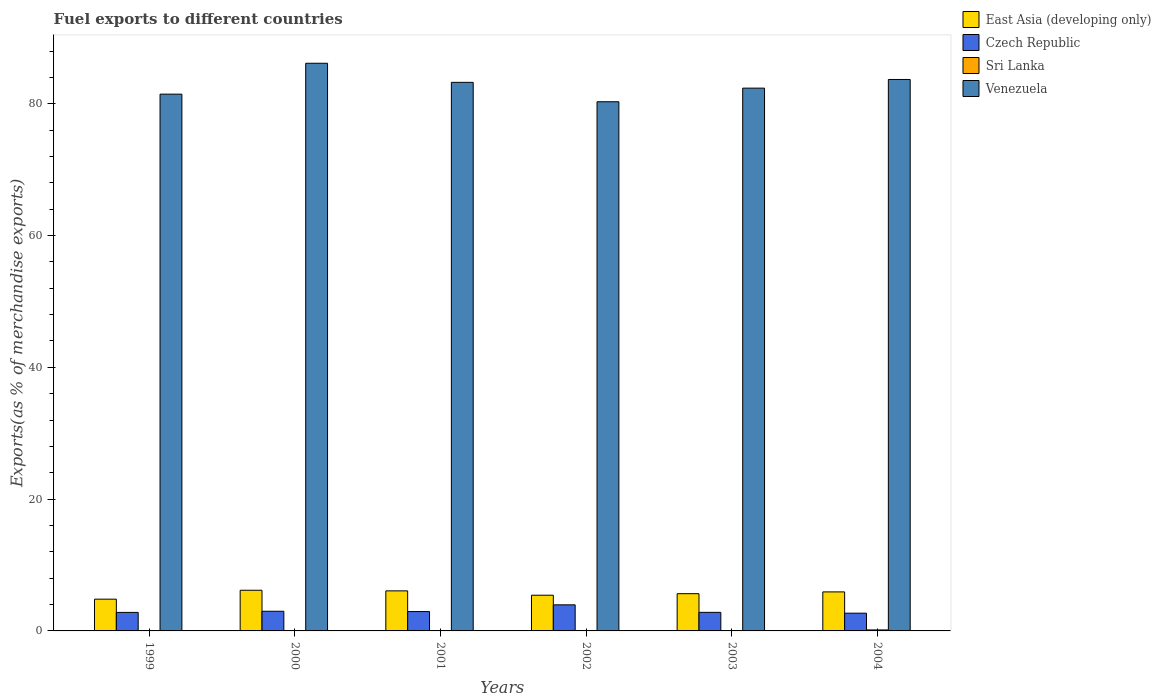How many bars are there on the 6th tick from the left?
Your response must be concise. 4. How many bars are there on the 2nd tick from the right?
Your answer should be very brief. 4. In how many cases, is the number of bars for a given year not equal to the number of legend labels?
Your answer should be compact. 0. What is the percentage of exports to different countries in Venezuela in 2002?
Offer a terse response. 80.3. Across all years, what is the maximum percentage of exports to different countries in Sri Lanka?
Your answer should be compact. 0.15. Across all years, what is the minimum percentage of exports to different countries in East Asia (developing only)?
Make the answer very short. 4.82. What is the total percentage of exports to different countries in Sri Lanka in the graph?
Offer a terse response. 0.24. What is the difference between the percentage of exports to different countries in Czech Republic in 2000 and that in 2001?
Your response must be concise. 0.04. What is the difference between the percentage of exports to different countries in Sri Lanka in 2000 and the percentage of exports to different countries in East Asia (developing only) in 1999?
Make the answer very short. -4.81. What is the average percentage of exports to different countries in East Asia (developing only) per year?
Ensure brevity in your answer.  5.68. In the year 2003, what is the difference between the percentage of exports to different countries in Sri Lanka and percentage of exports to different countries in Venezuela?
Your answer should be very brief. -82.35. In how many years, is the percentage of exports to different countries in East Asia (developing only) greater than 72 %?
Give a very brief answer. 0. What is the ratio of the percentage of exports to different countries in East Asia (developing only) in 2002 to that in 2003?
Offer a terse response. 0.96. Is the percentage of exports to different countries in Venezuela in 2000 less than that in 2001?
Provide a succinct answer. No. What is the difference between the highest and the second highest percentage of exports to different countries in Venezuela?
Your answer should be compact. 2.46. What is the difference between the highest and the lowest percentage of exports to different countries in Czech Republic?
Offer a very short reply. 1.27. Is the sum of the percentage of exports to different countries in East Asia (developing only) in 2001 and 2003 greater than the maximum percentage of exports to different countries in Sri Lanka across all years?
Your answer should be compact. Yes. Is it the case that in every year, the sum of the percentage of exports to different countries in East Asia (developing only) and percentage of exports to different countries in Venezuela is greater than the sum of percentage of exports to different countries in Sri Lanka and percentage of exports to different countries in Czech Republic?
Offer a very short reply. No. What does the 1st bar from the left in 2001 represents?
Ensure brevity in your answer.  East Asia (developing only). What does the 1st bar from the right in 2002 represents?
Ensure brevity in your answer.  Venezuela. Are all the bars in the graph horizontal?
Provide a succinct answer. No. Are the values on the major ticks of Y-axis written in scientific E-notation?
Your answer should be very brief. No. Does the graph contain any zero values?
Give a very brief answer. No. How many legend labels are there?
Give a very brief answer. 4. What is the title of the graph?
Make the answer very short. Fuel exports to different countries. What is the label or title of the X-axis?
Offer a very short reply. Years. What is the label or title of the Y-axis?
Make the answer very short. Exports(as % of merchandise exports). What is the Exports(as % of merchandise exports) in East Asia (developing only) in 1999?
Provide a short and direct response. 4.82. What is the Exports(as % of merchandise exports) of Czech Republic in 1999?
Offer a very short reply. 2.81. What is the Exports(as % of merchandise exports) of Sri Lanka in 1999?
Ensure brevity in your answer.  0.04. What is the Exports(as % of merchandise exports) of Venezuela in 1999?
Your response must be concise. 81.45. What is the Exports(as % of merchandise exports) in East Asia (developing only) in 2000?
Make the answer very short. 6.17. What is the Exports(as % of merchandise exports) of Czech Republic in 2000?
Keep it short and to the point. 2.98. What is the Exports(as % of merchandise exports) of Sri Lanka in 2000?
Your response must be concise. 0.01. What is the Exports(as % of merchandise exports) of Venezuela in 2000?
Keep it short and to the point. 86.14. What is the Exports(as % of merchandise exports) of East Asia (developing only) in 2001?
Provide a short and direct response. 6.08. What is the Exports(as % of merchandise exports) in Czech Republic in 2001?
Your answer should be compact. 2.94. What is the Exports(as % of merchandise exports) in Sri Lanka in 2001?
Ensure brevity in your answer.  0.01. What is the Exports(as % of merchandise exports) of Venezuela in 2001?
Ensure brevity in your answer.  83.24. What is the Exports(as % of merchandise exports) of East Asia (developing only) in 2002?
Offer a terse response. 5.42. What is the Exports(as % of merchandise exports) in Czech Republic in 2002?
Your answer should be compact. 3.96. What is the Exports(as % of merchandise exports) of Sri Lanka in 2002?
Give a very brief answer. 0.01. What is the Exports(as % of merchandise exports) in Venezuela in 2002?
Your response must be concise. 80.3. What is the Exports(as % of merchandise exports) of East Asia (developing only) in 2003?
Keep it short and to the point. 5.65. What is the Exports(as % of merchandise exports) of Czech Republic in 2003?
Offer a terse response. 2.82. What is the Exports(as % of merchandise exports) in Sri Lanka in 2003?
Offer a terse response. 0.02. What is the Exports(as % of merchandise exports) in Venezuela in 2003?
Offer a terse response. 82.37. What is the Exports(as % of merchandise exports) in East Asia (developing only) in 2004?
Your answer should be very brief. 5.92. What is the Exports(as % of merchandise exports) in Czech Republic in 2004?
Provide a short and direct response. 2.69. What is the Exports(as % of merchandise exports) in Sri Lanka in 2004?
Provide a short and direct response. 0.15. What is the Exports(as % of merchandise exports) in Venezuela in 2004?
Provide a succinct answer. 83.68. Across all years, what is the maximum Exports(as % of merchandise exports) of East Asia (developing only)?
Give a very brief answer. 6.17. Across all years, what is the maximum Exports(as % of merchandise exports) of Czech Republic?
Offer a terse response. 3.96. Across all years, what is the maximum Exports(as % of merchandise exports) in Sri Lanka?
Offer a very short reply. 0.15. Across all years, what is the maximum Exports(as % of merchandise exports) of Venezuela?
Offer a terse response. 86.14. Across all years, what is the minimum Exports(as % of merchandise exports) in East Asia (developing only)?
Your response must be concise. 4.82. Across all years, what is the minimum Exports(as % of merchandise exports) of Czech Republic?
Offer a terse response. 2.69. Across all years, what is the minimum Exports(as % of merchandise exports) of Sri Lanka?
Offer a very short reply. 0.01. Across all years, what is the minimum Exports(as % of merchandise exports) of Venezuela?
Offer a very short reply. 80.3. What is the total Exports(as % of merchandise exports) in East Asia (developing only) in the graph?
Make the answer very short. 34.06. What is the total Exports(as % of merchandise exports) in Czech Republic in the graph?
Give a very brief answer. 18.2. What is the total Exports(as % of merchandise exports) in Sri Lanka in the graph?
Your response must be concise. 0.24. What is the total Exports(as % of merchandise exports) in Venezuela in the graph?
Your response must be concise. 497.18. What is the difference between the Exports(as % of merchandise exports) in East Asia (developing only) in 1999 and that in 2000?
Your response must be concise. -1.35. What is the difference between the Exports(as % of merchandise exports) of Czech Republic in 1999 and that in 2000?
Ensure brevity in your answer.  -0.17. What is the difference between the Exports(as % of merchandise exports) of Sri Lanka in 1999 and that in 2000?
Make the answer very short. 0.03. What is the difference between the Exports(as % of merchandise exports) of Venezuela in 1999 and that in 2000?
Provide a succinct answer. -4.69. What is the difference between the Exports(as % of merchandise exports) of East Asia (developing only) in 1999 and that in 2001?
Your answer should be very brief. -1.26. What is the difference between the Exports(as % of merchandise exports) in Czech Republic in 1999 and that in 2001?
Offer a very short reply. -0.13. What is the difference between the Exports(as % of merchandise exports) in Sri Lanka in 1999 and that in 2001?
Give a very brief answer. 0.03. What is the difference between the Exports(as % of merchandise exports) of Venezuela in 1999 and that in 2001?
Keep it short and to the point. -1.79. What is the difference between the Exports(as % of merchandise exports) in East Asia (developing only) in 1999 and that in 2002?
Make the answer very short. -0.6. What is the difference between the Exports(as % of merchandise exports) in Czech Republic in 1999 and that in 2002?
Ensure brevity in your answer.  -1.15. What is the difference between the Exports(as % of merchandise exports) of Sri Lanka in 1999 and that in 2002?
Keep it short and to the point. 0.03. What is the difference between the Exports(as % of merchandise exports) in Venezuela in 1999 and that in 2002?
Your answer should be compact. 1.15. What is the difference between the Exports(as % of merchandise exports) in East Asia (developing only) in 1999 and that in 2003?
Give a very brief answer. -0.83. What is the difference between the Exports(as % of merchandise exports) of Czech Republic in 1999 and that in 2003?
Your answer should be very brief. -0.01. What is the difference between the Exports(as % of merchandise exports) of Sri Lanka in 1999 and that in 2003?
Ensure brevity in your answer.  0.02. What is the difference between the Exports(as % of merchandise exports) of Venezuela in 1999 and that in 2003?
Provide a short and direct response. -0.91. What is the difference between the Exports(as % of merchandise exports) in East Asia (developing only) in 1999 and that in 2004?
Your answer should be very brief. -1.1. What is the difference between the Exports(as % of merchandise exports) of Czech Republic in 1999 and that in 2004?
Keep it short and to the point. 0.12. What is the difference between the Exports(as % of merchandise exports) of Sri Lanka in 1999 and that in 2004?
Your response must be concise. -0.11. What is the difference between the Exports(as % of merchandise exports) of Venezuela in 1999 and that in 2004?
Provide a succinct answer. -2.23. What is the difference between the Exports(as % of merchandise exports) of East Asia (developing only) in 2000 and that in 2001?
Ensure brevity in your answer.  0.09. What is the difference between the Exports(as % of merchandise exports) in Czech Republic in 2000 and that in 2001?
Your answer should be very brief. 0.04. What is the difference between the Exports(as % of merchandise exports) in Sri Lanka in 2000 and that in 2001?
Provide a short and direct response. -0.01. What is the difference between the Exports(as % of merchandise exports) in Venezuela in 2000 and that in 2001?
Your answer should be compact. 2.9. What is the difference between the Exports(as % of merchandise exports) of East Asia (developing only) in 2000 and that in 2002?
Give a very brief answer. 0.75. What is the difference between the Exports(as % of merchandise exports) of Czech Republic in 2000 and that in 2002?
Your response must be concise. -0.97. What is the difference between the Exports(as % of merchandise exports) of Sri Lanka in 2000 and that in 2002?
Keep it short and to the point. -0. What is the difference between the Exports(as % of merchandise exports) in Venezuela in 2000 and that in 2002?
Make the answer very short. 5.84. What is the difference between the Exports(as % of merchandise exports) of East Asia (developing only) in 2000 and that in 2003?
Make the answer very short. 0.52. What is the difference between the Exports(as % of merchandise exports) of Czech Republic in 2000 and that in 2003?
Make the answer very short. 0.17. What is the difference between the Exports(as % of merchandise exports) in Sri Lanka in 2000 and that in 2003?
Make the answer very short. -0.01. What is the difference between the Exports(as % of merchandise exports) in Venezuela in 2000 and that in 2003?
Provide a succinct answer. 3.77. What is the difference between the Exports(as % of merchandise exports) in East Asia (developing only) in 2000 and that in 2004?
Your answer should be very brief. 0.25. What is the difference between the Exports(as % of merchandise exports) in Czech Republic in 2000 and that in 2004?
Provide a succinct answer. 0.29. What is the difference between the Exports(as % of merchandise exports) in Sri Lanka in 2000 and that in 2004?
Offer a very short reply. -0.14. What is the difference between the Exports(as % of merchandise exports) of Venezuela in 2000 and that in 2004?
Make the answer very short. 2.46. What is the difference between the Exports(as % of merchandise exports) in East Asia (developing only) in 2001 and that in 2002?
Offer a terse response. 0.66. What is the difference between the Exports(as % of merchandise exports) in Czech Republic in 2001 and that in 2002?
Offer a very short reply. -1.02. What is the difference between the Exports(as % of merchandise exports) of Sri Lanka in 2001 and that in 2002?
Make the answer very short. 0. What is the difference between the Exports(as % of merchandise exports) in Venezuela in 2001 and that in 2002?
Keep it short and to the point. 2.94. What is the difference between the Exports(as % of merchandise exports) of East Asia (developing only) in 2001 and that in 2003?
Make the answer very short. 0.43. What is the difference between the Exports(as % of merchandise exports) in Czech Republic in 2001 and that in 2003?
Ensure brevity in your answer.  0.12. What is the difference between the Exports(as % of merchandise exports) in Sri Lanka in 2001 and that in 2003?
Your answer should be compact. -0.01. What is the difference between the Exports(as % of merchandise exports) in Venezuela in 2001 and that in 2003?
Keep it short and to the point. 0.88. What is the difference between the Exports(as % of merchandise exports) in East Asia (developing only) in 2001 and that in 2004?
Your answer should be very brief. 0.16. What is the difference between the Exports(as % of merchandise exports) in Czech Republic in 2001 and that in 2004?
Ensure brevity in your answer.  0.25. What is the difference between the Exports(as % of merchandise exports) in Sri Lanka in 2001 and that in 2004?
Your answer should be very brief. -0.14. What is the difference between the Exports(as % of merchandise exports) of Venezuela in 2001 and that in 2004?
Offer a very short reply. -0.44. What is the difference between the Exports(as % of merchandise exports) in East Asia (developing only) in 2002 and that in 2003?
Provide a short and direct response. -0.23. What is the difference between the Exports(as % of merchandise exports) of Czech Republic in 2002 and that in 2003?
Your answer should be very brief. 1.14. What is the difference between the Exports(as % of merchandise exports) in Sri Lanka in 2002 and that in 2003?
Provide a succinct answer. -0.01. What is the difference between the Exports(as % of merchandise exports) in Venezuela in 2002 and that in 2003?
Make the answer very short. -2.07. What is the difference between the Exports(as % of merchandise exports) of East Asia (developing only) in 2002 and that in 2004?
Offer a very short reply. -0.5. What is the difference between the Exports(as % of merchandise exports) of Czech Republic in 2002 and that in 2004?
Ensure brevity in your answer.  1.27. What is the difference between the Exports(as % of merchandise exports) in Sri Lanka in 2002 and that in 2004?
Keep it short and to the point. -0.14. What is the difference between the Exports(as % of merchandise exports) of Venezuela in 2002 and that in 2004?
Keep it short and to the point. -3.38. What is the difference between the Exports(as % of merchandise exports) of East Asia (developing only) in 2003 and that in 2004?
Keep it short and to the point. -0.27. What is the difference between the Exports(as % of merchandise exports) of Czech Republic in 2003 and that in 2004?
Ensure brevity in your answer.  0.12. What is the difference between the Exports(as % of merchandise exports) of Sri Lanka in 2003 and that in 2004?
Provide a short and direct response. -0.13. What is the difference between the Exports(as % of merchandise exports) in Venezuela in 2003 and that in 2004?
Offer a very short reply. -1.31. What is the difference between the Exports(as % of merchandise exports) in East Asia (developing only) in 1999 and the Exports(as % of merchandise exports) in Czech Republic in 2000?
Make the answer very short. 1.83. What is the difference between the Exports(as % of merchandise exports) in East Asia (developing only) in 1999 and the Exports(as % of merchandise exports) in Sri Lanka in 2000?
Ensure brevity in your answer.  4.81. What is the difference between the Exports(as % of merchandise exports) in East Asia (developing only) in 1999 and the Exports(as % of merchandise exports) in Venezuela in 2000?
Ensure brevity in your answer.  -81.32. What is the difference between the Exports(as % of merchandise exports) of Czech Republic in 1999 and the Exports(as % of merchandise exports) of Sri Lanka in 2000?
Give a very brief answer. 2.8. What is the difference between the Exports(as % of merchandise exports) in Czech Republic in 1999 and the Exports(as % of merchandise exports) in Venezuela in 2000?
Ensure brevity in your answer.  -83.33. What is the difference between the Exports(as % of merchandise exports) in Sri Lanka in 1999 and the Exports(as % of merchandise exports) in Venezuela in 2000?
Make the answer very short. -86.1. What is the difference between the Exports(as % of merchandise exports) of East Asia (developing only) in 1999 and the Exports(as % of merchandise exports) of Czech Republic in 2001?
Offer a very short reply. 1.88. What is the difference between the Exports(as % of merchandise exports) in East Asia (developing only) in 1999 and the Exports(as % of merchandise exports) in Sri Lanka in 2001?
Provide a succinct answer. 4.81. What is the difference between the Exports(as % of merchandise exports) of East Asia (developing only) in 1999 and the Exports(as % of merchandise exports) of Venezuela in 2001?
Make the answer very short. -78.43. What is the difference between the Exports(as % of merchandise exports) of Czech Republic in 1999 and the Exports(as % of merchandise exports) of Sri Lanka in 2001?
Provide a short and direct response. 2.8. What is the difference between the Exports(as % of merchandise exports) of Czech Republic in 1999 and the Exports(as % of merchandise exports) of Venezuela in 2001?
Provide a short and direct response. -80.43. What is the difference between the Exports(as % of merchandise exports) of Sri Lanka in 1999 and the Exports(as % of merchandise exports) of Venezuela in 2001?
Your response must be concise. -83.2. What is the difference between the Exports(as % of merchandise exports) in East Asia (developing only) in 1999 and the Exports(as % of merchandise exports) in Czech Republic in 2002?
Your response must be concise. 0.86. What is the difference between the Exports(as % of merchandise exports) in East Asia (developing only) in 1999 and the Exports(as % of merchandise exports) in Sri Lanka in 2002?
Give a very brief answer. 4.81. What is the difference between the Exports(as % of merchandise exports) of East Asia (developing only) in 1999 and the Exports(as % of merchandise exports) of Venezuela in 2002?
Provide a succinct answer. -75.48. What is the difference between the Exports(as % of merchandise exports) in Czech Republic in 1999 and the Exports(as % of merchandise exports) in Sri Lanka in 2002?
Give a very brief answer. 2.8. What is the difference between the Exports(as % of merchandise exports) of Czech Republic in 1999 and the Exports(as % of merchandise exports) of Venezuela in 2002?
Make the answer very short. -77.49. What is the difference between the Exports(as % of merchandise exports) of Sri Lanka in 1999 and the Exports(as % of merchandise exports) of Venezuela in 2002?
Give a very brief answer. -80.26. What is the difference between the Exports(as % of merchandise exports) of East Asia (developing only) in 1999 and the Exports(as % of merchandise exports) of Czech Republic in 2003?
Your answer should be very brief. 2. What is the difference between the Exports(as % of merchandise exports) in East Asia (developing only) in 1999 and the Exports(as % of merchandise exports) in Sri Lanka in 2003?
Your answer should be very brief. 4.8. What is the difference between the Exports(as % of merchandise exports) of East Asia (developing only) in 1999 and the Exports(as % of merchandise exports) of Venezuela in 2003?
Your answer should be compact. -77.55. What is the difference between the Exports(as % of merchandise exports) of Czech Republic in 1999 and the Exports(as % of merchandise exports) of Sri Lanka in 2003?
Provide a short and direct response. 2.79. What is the difference between the Exports(as % of merchandise exports) of Czech Republic in 1999 and the Exports(as % of merchandise exports) of Venezuela in 2003?
Your answer should be compact. -79.56. What is the difference between the Exports(as % of merchandise exports) of Sri Lanka in 1999 and the Exports(as % of merchandise exports) of Venezuela in 2003?
Make the answer very short. -82.33. What is the difference between the Exports(as % of merchandise exports) of East Asia (developing only) in 1999 and the Exports(as % of merchandise exports) of Czech Republic in 2004?
Make the answer very short. 2.13. What is the difference between the Exports(as % of merchandise exports) in East Asia (developing only) in 1999 and the Exports(as % of merchandise exports) in Sri Lanka in 2004?
Provide a succinct answer. 4.67. What is the difference between the Exports(as % of merchandise exports) in East Asia (developing only) in 1999 and the Exports(as % of merchandise exports) in Venezuela in 2004?
Keep it short and to the point. -78.86. What is the difference between the Exports(as % of merchandise exports) in Czech Republic in 1999 and the Exports(as % of merchandise exports) in Sri Lanka in 2004?
Keep it short and to the point. 2.66. What is the difference between the Exports(as % of merchandise exports) of Czech Republic in 1999 and the Exports(as % of merchandise exports) of Venezuela in 2004?
Offer a terse response. -80.87. What is the difference between the Exports(as % of merchandise exports) of Sri Lanka in 1999 and the Exports(as % of merchandise exports) of Venezuela in 2004?
Your answer should be compact. -83.64. What is the difference between the Exports(as % of merchandise exports) in East Asia (developing only) in 2000 and the Exports(as % of merchandise exports) in Czech Republic in 2001?
Your answer should be very brief. 3.23. What is the difference between the Exports(as % of merchandise exports) of East Asia (developing only) in 2000 and the Exports(as % of merchandise exports) of Sri Lanka in 2001?
Make the answer very short. 6.16. What is the difference between the Exports(as % of merchandise exports) of East Asia (developing only) in 2000 and the Exports(as % of merchandise exports) of Venezuela in 2001?
Your answer should be very brief. -77.07. What is the difference between the Exports(as % of merchandise exports) of Czech Republic in 2000 and the Exports(as % of merchandise exports) of Sri Lanka in 2001?
Give a very brief answer. 2.97. What is the difference between the Exports(as % of merchandise exports) of Czech Republic in 2000 and the Exports(as % of merchandise exports) of Venezuela in 2001?
Offer a very short reply. -80.26. What is the difference between the Exports(as % of merchandise exports) of Sri Lanka in 2000 and the Exports(as % of merchandise exports) of Venezuela in 2001?
Provide a short and direct response. -83.24. What is the difference between the Exports(as % of merchandise exports) in East Asia (developing only) in 2000 and the Exports(as % of merchandise exports) in Czech Republic in 2002?
Give a very brief answer. 2.21. What is the difference between the Exports(as % of merchandise exports) in East Asia (developing only) in 2000 and the Exports(as % of merchandise exports) in Sri Lanka in 2002?
Your answer should be compact. 6.16. What is the difference between the Exports(as % of merchandise exports) of East Asia (developing only) in 2000 and the Exports(as % of merchandise exports) of Venezuela in 2002?
Your answer should be very brief. -74.13. What is the difference between the Exports(as % of merchandise exports) of Czech Republic in 2000 and the Exports(as % of merchandise exports) of Sri Lanka in 2002?
Ensure brevity in your answer.  2.97. What is the difference between the Exports(as % of merchandise exports) of Czech Republic in 2000 and the Exports(as % of merchandise exports) of Venezuela in 2002?
Offer a terse response. -77.32. What is the difference between the Exports(as % of merchandise exports) of Sri Lanka in 2000 and the Exports(as % of merchandise exports) of Venezuela in 2002?
Keep it short and to the point. -80.29. What is the difference between the Exports(as % of merchandise exports) in East Asia (developing only) in 2000 and the Exports(as % of merchandise exports) in Czech Republic in 2003?
Give a very brief answer. 3.35. What is the difference between the Exports(as % of merchandise exports) in East Asia (developing only) in 2000 and the Exports(as % of merchandise exports) in Sri Lanka in 2003?
Your answer should be compact. 6.15. What is the difference between the Exports(as % of merchandise exports) of East Asia (developing only) in 2000 and the Exports(as % of merchandise exports) of Venezuela in 2003?
Ensure brevity in your answer.  -76.2. What is the difference between the Exports(as % of merchandise exports) in Czech Republic in 2000 and the Exports(as % of merchandise exports) in Sri Lanka in 2003?
Give a very brief answer. 2.96. What is the difference between the Exports(as % of merchandise exports) in Czech Republic in 2000 and the Exports(as % of merchandise exports) in Venezuela in 2003?
Your answer should be very brief. -79.38. What is the difference between the Exports(as % of merchandise exports) in Sri Lanka in 2000 and the Exports(as % of merchandise exports) in Venezuela in 2003?
Offer a terse response. -82.36. What is the difference between the Exports(as % of merchandise exports) of East Asia (developing only) in 2000 and the Exports(as % of merchandise exports) of Czech Republic in 2004?
Give a very brief answer. 3.48. What is the difference between the Exports(as % of merchandise exports) of East Asia (developing only) in 2000 and the Exports(as % of merchandise exports) of Sri Lanka in 2004?
Your response must be concise. 6.02. What is the difference between the Exports(as % of merchandise exports) of East Asia (developing only) in 2000 and the Exports(as % of merchandise exports) of Venezuela in 2004?
Ensure brevity in your answer.  -77.51. What is the difference between the Exports(as % of merchandise exports) of Czech Republic in 2000 and the Exports(as % of merchandise exports) of Sri Lanka in 2004?
Offer a very short reply. 2.83. What is the difference between the Exports(as % of merchandise exports) in Czech Republic in 2000 and the Exports(as % of merchandise exports) in Venezuela in 2004?
Provide a succinct answer. -80.7. What is the difference between the Exports(as % of merchandise exports) in Sri Lanka in 2000 and the Exports(as % of merchandise exports) in Venezuela in 2004?
Your response must be concise. -83.67. What is the difference between the Exports(as % of merchandise exports) of East Asia (developing only) in 2001 and the Exports(as % of merchandise exports) of Czech Republic in 2002?
Your answer should be compact. 2.12. What is the difference between the Exports(as % of merchandise exports) of East Asia (developing only) in 2001 and the Exports(as % of merchandise exports) of Sri Lanka in 2002?
Offer a terse response. 6.07. What is the difference between the Exports(as % of merchandise exports) in East Asia (developing only) in 2001 and the Exports(as % of merchandise exports) in Venezuela in 2002?
Provide a short and direct response. -74.22. What is the difference between the Exports(as % of merchandise exports) of Czech Republic in 2001 and the Exports(as % of merchandise exports) of Sri Lanka in 2002?
Ensure brevity in your answer.  2.93. What is the difference between the Exports(as % of merchandise exports) in Czech Republic in 2001 and the Exports(as % of merchandise exports) in Venezuela in 2002?
Offer a terse response. -77.36. What is the difference between the Exports(as % of merchandise exports) of Sri Lanka in 2001 and the Exports(as % of merchandise exports) of Venezuela in 2002?
Offer a very short reply. -80.29. What is the difference between the Exports(as % of merchandise exports) in East Asia (developing only) in 2001 and the Exports(as % of merchandise exports) in Czech Republic in 2003?
Keep it short and to the point. 3.26. What is the difference between the Exports(as % of merchandise exports) of East Asia (developing only) in 2001 and the Exports(as % of merchandise exports) of Sri Lanka in 2003?
Offer a terse response. 6.06. What is the difference between the Exports(as % of merchandise exports) of East Asia (developing only) in 2001 and the Exports(as % of merchandise exports) of Venezuela in 2003?
Ensure brevity in your answer.  -76.29. What is the difference between the Exports(as % of merchandise exports) in Czech Republic in 2001 and the Exports(as % of merchandise exports) in Sri Lanka in 2003?
Give a very brief answer. 2.92. What is the difference between the Exports(as % of merchandise exports) of Czech Republic in 2001 and the Exports(as % of merchandise exports) of Venezuela in 2003?
Ensure brevity in your answer.  -79.43. What is the difference between the Exports(as % of merchandise exports) in Sri Lanka in 2001 and the Exports(as % of merchandise exports) in Venezuela in 2003?
Ensure brevity in your answer.  -82.35. What is the difference between the Exports(as % of merchandise exports) in East Asia (developing only) in 2001 and the Exports(as % of merchandise exports) in Czech Republic in 2004?
Your response must be concise. 3.38. What is the difference between the Exports(as % of merchandise exports) in East Asia (developing only) in 2001 and the Exports(as % of merchandise exports) in Sri Lanka in 2004?
Your answer should be compact. 5.93. What is the difference between the Exports(as % of merchandise exports) of East Asia (developing only) in 2001 and the Exports(as % of merchandise exports) of Venezuela in 2004?
Provide a short and direct response. -77.6. What is the difference between the Exports(as % of merchandise exports) of Czech Republic in 2001 and the Exports(as % of merchandise exports) of Sri Lanka in 2004?
Ensure brevity in your answer.  2.79. What is the difference between the Exports(as % of merchandise exports) of Czech Republic in 2001 and the Exports(as % of merchandise exports) of Venezuela in 2004?
Provide a succinct answer. -80.74. What is the difference between the Exports(as % of merchandise exports) of Sri Lanka in 2001 and the Exports(as % of merchandise exports) of Venezuela in 2004?
Provide a short and direct response. -83.67. What is the difference between the Exports(as % of merchandise exports) of East Asia (developing only) in 2002 and the Exports(as % of merchandise exports) of Czech Republic in 2003?
Provide a succinct answer. 2.6. What is the difference between the Exports(as % of merchandise exports) in East Asia (developing only) in 2002 and the Exports(as % of merchandise exports) in Sri Lanka in 2003?
Keep it short and to the point. 5.4. What is the difference between the Exports(as % of merchandise exports) of East Asia (developing only) in 2002 and the Exports(as % of merchandise exports) of Venezuela in 2003?
Offer a very short reply. -76.95. What is the difference between the Exports(as % of merchandise exports) in Czech Republic in 2002 and the Exports(as % of merchandise exports) in Sri Lanka in 2003?
Your answer should be compact. 3.94. What is the difference between the Exports(as % of merchandise exports) of Czech Republic in 2002 and the Exports(as % of merchandise exports) of Venezuela in 2003?
Make the answer very short. -78.41. What is the difference between the Exports(as % of merchandise exports) of Sri Lanka in 2002 and the Exports(as % of merchandise exports) of Venezuela in 2003?
Ensure brevity in your answer.  -82.36. What is the difference between the Exports(as % of merchandise exports) in East Asia (developing only) in 2002 and the Exports(as % of merchandise exports) in Czech Republic in 2004?
Keep it short and to the point. 2.73. What is the difference between the Exports(as % of merchandise exports) of East Asia (developing only) in 2002 and the Exports(as % of merchandise exports) of Sri Lanka in 2004?
Offer a terse response. 5.27. What is the difference between the Exports(as % of merchandise exports) in East Asia (developing only) in 2002 and the Exports(as % of merchandise exports) in Venezuela in 2004?
Provide a succinct answer. -78.26. What is the difference between the Exports(as % of merchandise exports) of Czech Republic in 2002 and the Exports(as % of merchandise exports) of Sri Lanka in 2004?
Offer a very short reply. 3.81. What is the difference between the Exports(as % of merchandise exports) of Czech Republic in 2002 and the Exports(as % of merchandise exports) of Venezuela in 2004?
Provide a short and direct response. -79.72. What is the difference between the Exports(as % of merchandise exports) of Sri Lanka in 2002 and the Exports(as % of merchandise exports) of Venezuela in 2004?
Offer a terse response. -83.67. What is the difference between the Exports(as % of merchandise exports) of East Asia (developing only) in 2003 and the Exports(as % of merchandise exports) of Czech Republic in 2004?
Give a very brief answer. 2.96. What is the difference between the Exports(as % of merchandise exports) of East Asia (developing only) in 2003 and the Exports(as % of merchandise exports) of Sri Lanka in 2004?
Your answer should be compact. 5.5. What is the difference between the Exports(as % of merchandise exports) of East Asia (developing only) in 2003 and the Exports(as % of merchandise exports) of Venezuela in 2004?
Offer a very short reply. -78.03. What is the difference between the Exports(as % of merchandise exports) of Czech Republic in 2003 and the Exports(as % of merchandise exports) of Sri Lanka in 2004?
Offer a terse response. 2.67. What is the difference between the Exports(as % of merchandise exports) in Czech Republic in 2003 and the Exports(as % of merchandise exports) in Venezuela in 2004?
Make the answer very short. -80.86. What is the difference between the Exports(as % of merchandise exports) of Sri Lanka in 2003 and the Exports(as % of merchandise exports) of Venezuela in 2004?
Give a very brief answer. -83.66. What is the average Exports(as % of merchandise exports) in East Asia (developing only) per year?
Your answer should be very brief. 5.68. What is the average Exports(as % of merchandise exports) of Czech Republic per year?
Keep it short and to the point. 3.03. What is the average Exports(as % of merchandise exports) in Sri Lanka per year?
Keep it short and to the point. 0.04. What is the average Exports(as % of merchandise exports) in Venezuela per year?
Give a very brief answer. 82.86. In the year 1999, what is the difference between the Exports(as % of merchandise exports) of East Asia (developing only) and Exports(as % of merchandise exports) of Czech Republic?
Make the answer very short. 2.01. In the year 1999, what is the difference between the Exports(as % of merchandise exports) of East Asia (developing only) and Exports(as % of merchandise exports) of Sri Lanka?
Give a very brief answer. 4.78. In the year 1999, what is the difference between the Exports(as % of merchandise exports) in East Asia (developing only) and Exports(as % of merchandise exports) in Venezuela?
Your answer should be compact. -76.64. In the year 1999, what is the difference between the Exports(as % of merchandise exports) of Czech Republic and Exports(as % of merchandise exports) of Sri Lanka?
Keep it short and to the point. 2.77. In the year 1999, what is the difference between the Exports(as % of merchandise exports) of Czech Republic and Exports(as % of merchandise exports) of Venezuela?
Make the answer very short. -78.64. In the year 1999, what is the difference between the Exports(as % of merchandise exports) in Sri Lanka and Exports(as % of merchandise exports) in Venezuela?
Offer a terse response. -81.41. In the year 2000, what is the difference between the Exports(as % of merchandise exports) in East Asia (developing only) and Exports(as % of merchandise exports) in Czech Republic?
Provide a succinct answer. 3.19. In the year 2000, what is the difference between the Exports(as % of merchandise exports) in East Asia (developing only) and Exports(as % of merchandise exports) in Sri Lanka?
Ensure brevity in your answer.  6.16. In the year 2000, what is the difference between the Exports(as % of merchandise exports) of East Asia (developing only) and Exports(as % of merchandise exports) of Venezuela?
Offer a terse response. -79.97. In the year 2000, what is the difference between the Exports(as % of merchandise exports) of Czech Republic and Exports(as % of merchandise exports) of Sri Lanka?
Give a very brief answer. 2.98. In the year 2000, what is the difference between the Exports(as % of merchandise exports) in Czech Republic and Exports(as % of merchandise exports) in Venezuela?
Provide a succinct answer. -83.16. In the year 2000, what is the difference between the Exports(as % of merchandise exports) in Sri Lanka and Exports(as % of merchandise exports) in Venezuela?
Provide a short and direct response. -86.13. In the year 2001, what is the difference between the Exports(as % of merchandise exports) in East Asia (developing only) and Exports(as % of merchandise exports) in Czech Republic?
Give a very brief answer. 3.14. In the year 2001, what is the difference between the Exports(as % of merchandise exports) in East Asia (developing only) and Exports(as % of merchandise exports) in Sri Lanka?
Your answer should be compact. 6.07. In the year 2001, what is the difference between the Exports(as % of merchandise exports) in East Asia (developing only) and Exports(as % of merchandise exports) in Venezuela?
Give a very brief answer. -77.17. In the year 2001, what is the difference between the Exports(as % of merchandise exports) of Czech Republic and Exports(as % of merchandise exports) of Sri Lanka?
Your answer should be very brief. 2.93. In the year 2001, what is the difference between the Exports(as % of merchandise exports) in Czech Republic and Exports(as % of merchandise exports) in Venezuela?
Ensure brevity in your answer.  -80.3. In the year 2001, what is the difference between the Exports(as % of merchandise exports) in Sri Lanka and Exports(as % of merchandise exports) in Venezuela?
Offer a terse response. -83.23. In the year 2002, what is the difference between the Exports(as % of merchandise exports) in East Asia (developing only) and Exports(as % of merchandise exports) in Czech Republic?
Give a very brief answer. 1.46. In the year 2002, what is the difference between the Exports(as % of merchandise exports) of East Asia (developing only) and Exports(as % of merchandise exports) of Sri Lanka?
Your answer should be compact. 5.41. In the year 2002, what is the difference between the Exports(as % of merchandise exports) in East Asia (developing only) and Exports(as % of merchandise exports) in Venezuela?
Offer a very short reply. -74.88. In the year 2002, what is the difference between the Exports(as % of merchandise exports) in Czech Republic and Exports(as % of merchandise exports) in Sri Lanka?
Your answer should be compact. 3.95. In the year 2002, what is the difference between the Exports(as % of merchandise exports) in Czech Republic and Exports(as % of merchandise exports) in Venezuela?
Offer a very short reply. -76.34. In the year 2002, what is the difference between the Exports(as % of merchandise exports) of Sri Lanka and Exports(as % of merchandise exports) of Venezuela?
Keep it short and to the point. -80.29. In the year 2003, what is the difference between the Exports(as % of merchandise exports) in East Asia (developing only) and Exports(as % of merchandise exports) in Czech Republic?
Provide a short and direct response. 2.83. In the year 2003, what is the difference between the Exports(as % of merchandise exports) of East Asia (developing only) and Exports(as % of merchandise exports) of Sri Lanka?
Provide a short and direct response. 5.63. In the year 2003, what is the difference between the Exports(as % of merchandise exports) of East Asia (developing only) and Exports(as % of merchandise exports) of Venezuela?
Provide a succinct answer. -76.71. In the year 2003, what is the difference between the Exports(as % of merchandise exports) of Czech Republic and Exports(as % of merchandise exports) of Sri Lanka?
Your response must be concise. 2.8. In the year 2003, what is the difference between the Exports(as % of merchandise exports) in Czech Republic and Exports(as % of merchandise exports) in Venezuela?
Offer a very short reply. -79.55. In the year 2003, what is the difference between the Exports(as % of merchandise exports) of Sri Lanka and Exports(as % of merchandise exports) of Venezuela?
Ensure brevity in your answer.  -82.35. In the year 2004, what is the difference between the Exports(as % of merchandise exports) of East Asia (developing only) and Exports(as % of merchandise exports) of Czech Republic?
Ensure brevity in your answer.  3.23. In the year 2004, what is the difference between the Exports(as % of merchandise exports) of East Asia (developing only) and Exports(as % of merchandise exports) of Sri Lanka?
Keep it short and to the point. 5.77. In the year 2004, what is the difference between the Exports(as % of merchandise exports) in East Asia (developing only) and Exports(as % of merchandise exports) in Venezuela?
Provide a short and direct response. -77.76. In the year 2004, what is the difference between the Exports(as % of merchandise exports) in Czech Republic and Exports(as % of merchandise exports) in Sri Lanka?
Provide a short and direct response. 2.54. In the year 2004, what is the difference between the Exports(as % of merchandise exports) of Czech Republic and Exports(as % of merchandise exports) of Venezuela?
Your response must be concise. -80.99. In the year 2004, what is the difference between the Exports(as % of merchandise exports) of Sri Lanka and Exports(as % of merchandise exports) of Venezuela?
Give a very brief answer. -83.53. What is the ratio of the Exports(as % of merchandise exports) of East Asia (developing only) in 1999 to that in 2000?
Your answer should be very brief. 0.78. What is the ratio of the Exports(as % of merchandise exports) of Czech Republic in 1999 to that in 2000?
Provide a succinct answer. 0.94. What is the ratio of the Exports(as % of merchandise exports) in Sri Lanka in 1999 to that in 2000?
Provide a succinct answer. 6.35. What is the ratio of the Exports(as % of merchandise exports) of Venezuela in 1999 to that in 2000?
Your answer should be very brief. 0.95. What is the ratio of the Exports(as % of merchandise exports) in East Asia (developing only) in 1999 to that in 2001?
Your answer should be compact. 0.79. What is the ratio of the Exports(as % of merchandise exports) in Czech Republic in 1999 to that in 2001?
Your response must be concise. 0.96. What is the ratio of the Exports(as % of merchandise exports) in Sri Lanka in 1999 to that in 2001?
Provide a short and direct response. 3.48. What is the ratio of the Exports(as % of merchandise exports) of Venezuela in 1999 to that in 2001?
Your response must be concise. 0.98. What is the ratio of the Exports(as % of merchandise exports) of East Asia (developing only) in 1999 to that in 2002?
Make the answer very short. 0.89. What is the ratio of the Exports(as % of merchandise exports) of Czech Republic in 1999 to that in 2002?
Your response must be concise. 0.71. What is the ratio of the Exports(as % of merchandise exports) in Sri Lanka in 1999 to that in 2002?
Your response must be concise. 3.89. What is the ratio of the Exports(as % of merchandise exports) in Venezuela in 1999 to that in 2002?
Offer a very short reply. 1.01. What is the ratio of the Exports(as % of merchandise exports) of East Asia (developing only) in 1999 to that in 2003?
Your response must be concise. 0.85. What is the ratio of the Exports(as % of merchandise exports) of Czech Republic in 1999 to that in 2003?
Provide a succinct answer. 1. What is the ratio of the Exports(as % of merchandise exports) in Sri Lanka in 1999 to that in 2003?
Give a very brief answer. 2.03. What is the ratio of the Exports(as % of merchandise exports) in Venezuela in 1999 to that in 2003?
Keep it short and to the point. 0.99. What is the ratio of the Exports(as % of merchandise exports) of East Asia (developing only) in 1999 to that in 2004?
Your answer should be compact. 0.81. What is the ratio of the Exports(as % of merchandise exports) in Czech Republic in 1999 to that in 2004?
Make the answer very short. 1.04. What is the ratio of the Exports(as % of merchandise exports) of Sri Lanka in 1999 to that in 2004?
Your response must be concise. 0.26. What is the ratio of the Exports(as % of merchandise exports) in Venezuela in 1999 to that in 2004?
Make the answer very short. 0.97. What is the ratio of the Exports(as % of merchandise exports) in East Asia (developing only) in 2000 to that in 2001?
Your answer should be compact. 1.02. What is the ratio of the Exports(as % of merchandise exports) in Czech Republic in 2000 to that in 2001?
Keep it short and to the point. 1.02. What is the ratio of the Exports(as % of merchandise exports) in Sri Lanka in 2000 to that in 2001?
Provide a succinct answer. 0.55. What is the ratio of the Exports(as % of merchandise exports) of Venezuela in 2000 to that in 2001?
Your answer should be very brief. 1.03. What is the ratio of the Exports(as % of merchandise exports) of East Asia (developing only) in 2000 to that in 2002?
Provide a short and direct response. 1.14. What is the ratio of the Exports(as % of merchandise exports) in Czech Republic in 2000 to that in 2002?
Offer a very short reply. 0.75. What is the ratio of the Exports(as % of merchandise exports) in Sri Lanka in 2000 to that in 2002?
Offer a very short reply. 0.61. What is the ratio of the Exports(as % of merchandise exports) of Venezuela in 2000 to that in 2002?
Offer a very short reply. 1.07. What is the ratio of the Exports(as % of merchandise exports) of East Asia (developing only) in 2000 to that in 2003?
Make the answer very short. 1.09. What is the ratio of the Exports(as % of merchandise exports) in Czech Republic in 2000 to that in 2003?
Provide a short and direct response. 1.06. What is the ratio of the Exports(as % of merchandise exports) of Sri Lanka in 2000 to that in 2003?
Give a very brief answer. 0.32. What is the ratio of the Exports(as % of merchandise exports) of Venezuela in 2000 to that in 2003?
Your answer should be compact. 1.05. What is the ratio of the Exports(as % of merchandise exports) of East Asia (developing only) in 2000 to that in 2004?
Keep it short and to the point. 1.04. What is the ratio of the Exports(as % of merchandise exports) in Czech Republic in 2000 to that in 2004?
Make the answer very short. 1.11. What is the ratio of the Exports(as % of merchandise exports) of Sri Lanka in 2000 to that in 2004?
Make the answer very short. 0.04. What is the ratio of the Exports(as % of merchandise exports) of Venezuela in 2000 to that in 2004?
Offer a terse response. 1.03. What is the ratio of the Exports(as % of merchandise exports) of East Asia (developing only) in 2001 to that in 2002?
Make the answer very short. 1.12. What is the ratio of the Exports(as % of merchandise exports) in Czech Republic in 2001 to that in 2002?
Offer a terse response. 0.74. What is the ratio of the Exports(as % of merchandise exports) of Sri Lanka in 2001 to that in 2002?
Provide a succinct answer. 1.12. What is the ratio of the Exports(as % of merchandise exports) in Venezuela in 2001 to that in 2002?
Your answer should be compact. 1.04. What is the ratio of the Exports(as % of merchandise exports) in East Asia (developing only) in 2001 to that in 2003?
Keep it short and to the point. 1.08. What is the ratio of the Exports(as % of merchandise exports) of Czech Republic in 2001 to that in 2003?
Offer a very short reply. 1.04. What is the ratio of the Exports(as % of merchandise exports) in Sri Lanka in 2001 to that in 2003?
Your answer should be very brief. 0.58. What is the ratio of the Exports(as % of merchandise exports) of Venezuela in 2001 to that in 2003?
Your response must be concise. 1.01. What is the ratio of the Exports(as % of merchandise exports) in East Asia (developing only) in 2001 to that in 2004?
Your answer should be compact. 1.03. What is the ratio of the Exports(as % of merchandise exports) of Czech Republic in 2001 to that in 2004?
Provide a succinct answer. 1.09. What is the ratio of the Exports(as % of merchandise exports) in Sri Lanka in 2001 to that in 2004?
Provide a succinct answer. 0.07. What is the ratio of the Exports(as % of merchandise exports) in East Asia (developing only) in 2002 to that in 2003?
Your answer should be compact. 0.96. What is the ratio of the Exports(as % of merchandise exports) in Czech Republic in 2002 to that in 2003?
Make the answer very short. 1.41. What is the ratio of the Exports(as % of merchandise exports) of Sri Lanka in 2002 to that in 2003?
Keep it short and to the point. 0.52. What is the ratio of the Exports(as % of merchandise exports) in Venezuela in 2002 to that in 2003?
Provide a succinct answer. 0.97. What is the ratio of the Exports(as % of merchandise exports) in East Asia (developing only) in 2002 to that in 2004?
Give a very brief answer. 0.92. What is the ratio of the Exports(as % of merchandise exports) of Czech Republic in 2002 to that in 2004?
Give a very brief answer. 1.47. What is the ratio of the Exports(as % of merchandise exports) of Sri Lanka in 2002 to that in 2004?
Provide a short and direct response. 0.07. What is the ratio of the Exports(as % of merchandise exports) of Venezuela in 2002 to that in 2004?
Give a very brief answer. 0.96. What is the ratio of the Exports(as % of merchandise exports) of East Asia (developing only) in 2003 to that in 2004?
Give a very brief answer. 0.95. What is the ratio of the Exports(as % of merchandise exports) of Czech Republic in 2003 to that in 2004?
Your answer should be compact. 1.05. What is the ratio of the Exports(as % of merchandise exports) in Sri Lanka in 2003 to that in 2004?
Give a very brief answer. 0.13. What is the ratio of the Exports(as % of merchandise exports) in Venezuela in 2003 to that in 2004?
Ensure brevity in your answer.  0.98. What is the difference between the highest and the second highest Exports(as % of merchandise exports) of East Asia (developing only)?
Your response must be concise. 0.09. What is the difference between the highest and the second highest Exports(as % of merchandise exports) in Sri Lanka?
Provide a succinct answer. 0.11. What is the difference between the highest and the second highest Exports(as % of merchandise exports) in Venezuela?
Provide a succinct answer. 2.46. What is the difference between the highest and the lowest Exports(as % of merchandise exports) in East Asia (developing only)?
Your answer should be compact. 1.35. What is the difference between the highest and the lowest Exports(as % of merchandise exports) of Czech Republic?
Provide a succinct answer. 1.27. What is the difference between the highest and the lowest Exports(as % of merchandise exports) in Sri Lanka?
Provide a short and direct response. 0.14. What is the difference between the highest and the lowest Exports(as % of merchandise exports) in Venezuela?
Your answer should be compact. 5.84. 